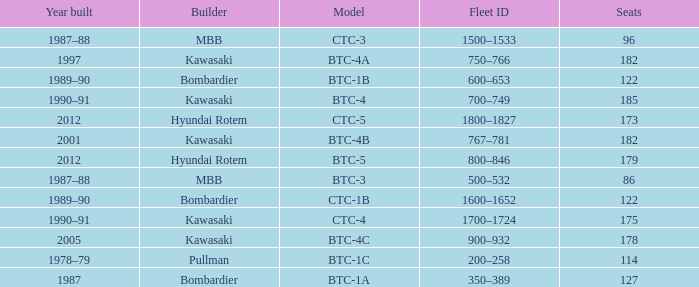For the train built in 2012 with less than 179 seats, what is the Fleet ID? 1800–1827. 